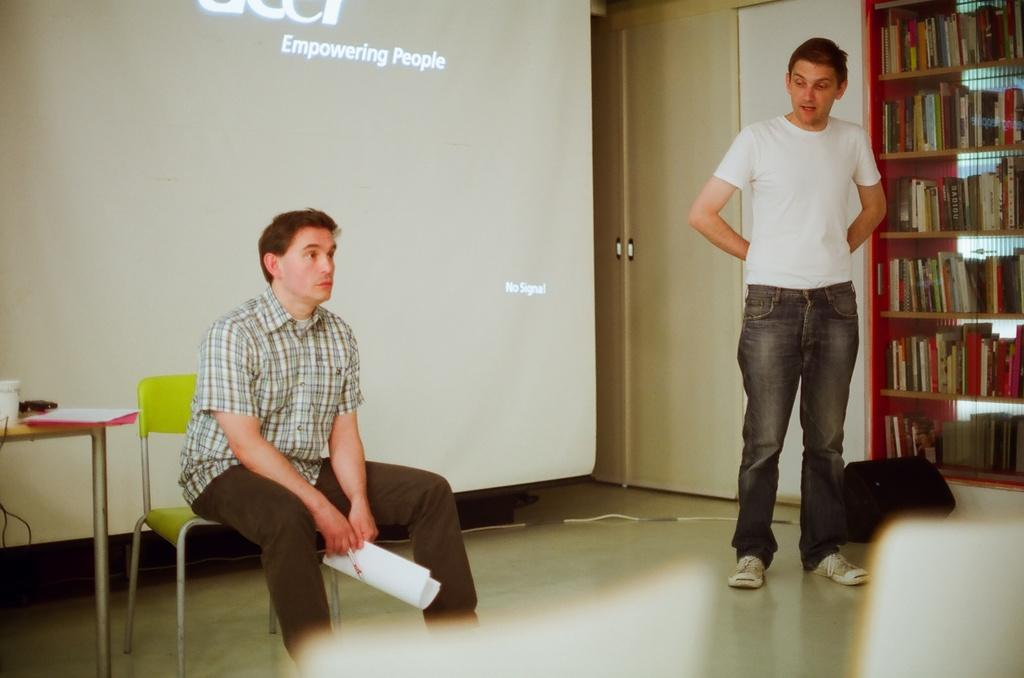What is the position of the man in the image? There is a man standing in the image. What is the standing man doing? The standing man is speaking. What is the position of the other man in the image? There is another man sitting in the image. What is the sitting man holding? The sitting man has papers in his hand. What might be happening between the two men in the image? The two men appear to be engaged in a conversation. What type of cherries can be seen on the battlefield in the image? There is no battlefield or cherries present in the image. What is the purpose of the mailbox in the image? There is no mailbox present in the image. 